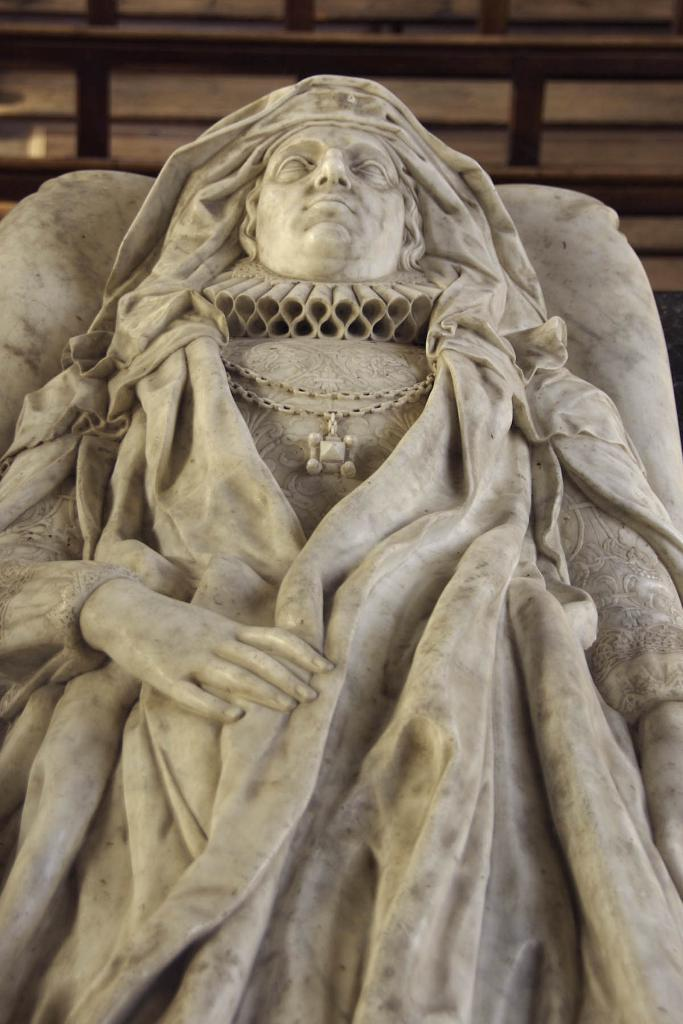What is the main subject of the image? The main subject of the image is a sculpture of a person. What material is the sculpture made of? The sculpture is carved from stone. What can be seen in the background of the image? There is a wooden fence in the background of the image. How does the sculpture influence the wind in the image? The sculpture does not influence the wind in the image, as it is a static object made of stone. 